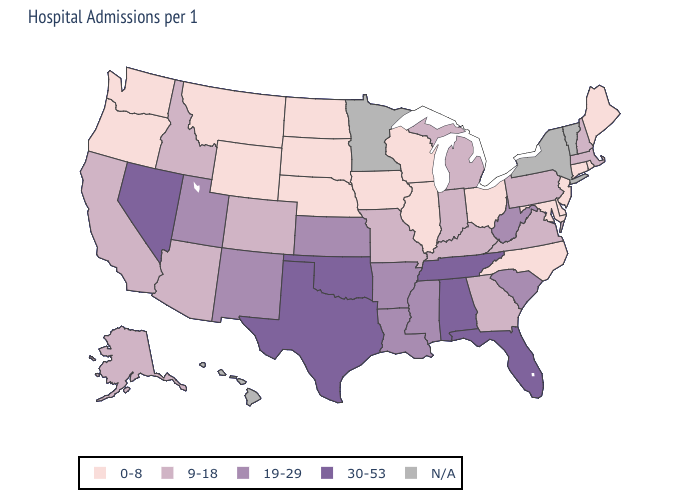Which states hav the highest value in the South?
Short answer required. Alabama, Florida, Oklahoma, Tennessee, Texas. What is the value of West Virginia?
Write a very short answer. 19-29. Does New Jersey have the highest value in the Northeast?
Write a very short answer. No. What is the highest value in states that border Washington?
Keep it brief. 9-18. Name the states that have a value in the range 19-29?
Keep it brief. Arkansas, Kansas, Louisiana, Mississippi, New Mexico, South Carolina, Utah, West Virginia. Which states have the highest value in the USA?
Write a very short answer. Alabama, Florida, Nevada, Oklahoma, Tennessee, Texas. Among the states that border Illinois , which have the lowest value?
Quick response, please. Iowa, Wisconsin. What is the value of Oklahoma?
Answer briefly. 30-53. How many symbols are there in the legend?
Keep it brief. 5. Name the states that have a value in the range N/A?
Concise answer only. Hawaii, Minnesota, New York, Vermont. Name the states that have a value in the range 9-18?
Short answer required. Alaska, Arizona, California, Colorado, Georgia, Idaho, Indiana, Kentucky, Massachusetts, Michigan, Missouri, New Hampshire, Pennsylvania, Virginia. Does the map have missing data?
Concise answer only. Yes. Among the states that border Florida , which have the highest value?
Quick response, please. Alabama. What is the value of Mississippi?
Give a very brief answer. 19-29. 